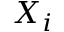<formula> <loc_0><loc_0><loc_500><loc_500>X _ { i }</formula> 